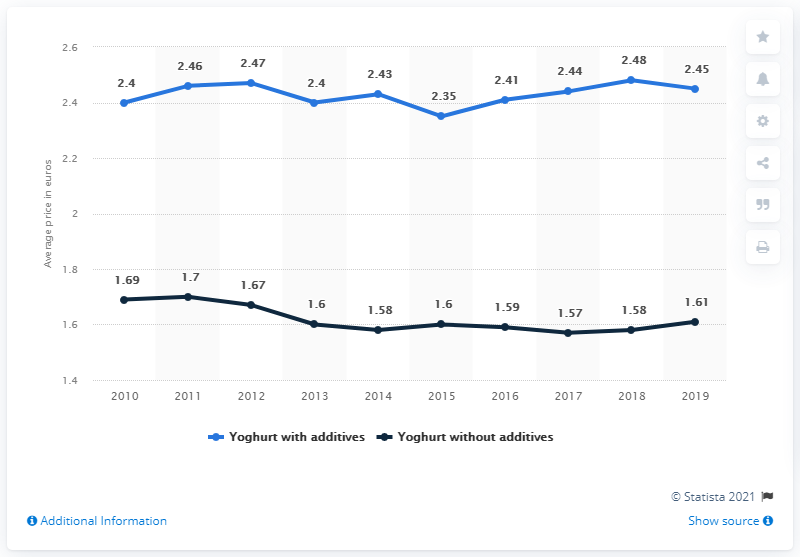Draw attention to some important aspects in this diagram. In 2010, the value and extent of a certain topic increased by 0.05 compared to the previous year. This discussion revolves around a food item called yoghurt with additives. In 2018, Spain had the highest average price for yoghurt with additives. 